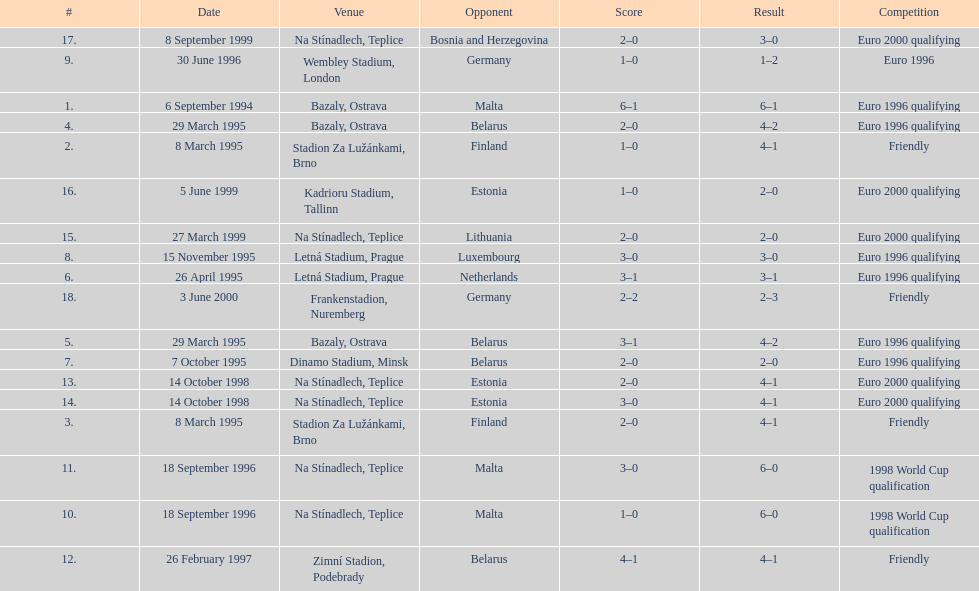List the opponent in which the result was the least out of all the results. Germany. Can you give me this table as a dict? {'header': ['#', 'Date', 'Venue', 'Opponent', 'Score', 'Result', 'Competition'], 'rows': [['17.', '8 September 1999', 'Na Stínadlech, Teplice', 'Bosnia and Herzegovina', '2–0', '3–0', 'Euro 2000 qualifying'], ['9.', '30 June 1996', 'Wembley Stadium, London', 'Germany', '1–0', '1–2', 'Euro 1996'], ['1.', '6 September 1994', 'Bazaly, Ostrava', 'Malta', '6–1', '6–1', 'Euro 1996 qualifying'], ['4.', '29 March 1995', 'Bazaly, Ostrava', 'Belarus', '2–0', '4–2', 'Euro 1996 qualifying'], ['2.', '8 March 1995', 'Stadion Za Lužánkami, Brno', 'Finland', '1–0', '4–1', 'Friendly'], ['16.', '5 June 1999', 'Kadrioru Stadium, Tallinn', 'Estonia', '1–0', '2–0', 'Euro 2000 qualifying'], ['15.', '27 March 1999', 'Na Stínadlech, Teplice', 'Lithuania', '2–0', '2–0', 'Euro 2000 qualifying'], ['8.', '15 November 1995', 'Letná Stadium, Prague', 'Luxembourg', '3–0', '3–0', 'Euro 1996 qualifying'], ['6.', '26 April 1995', 'Letná Stadium, Prague', 'Netherlands', '3–1', '3–1', 'Euro 1996 qualifying'], ['18.', '3 June 2000', 'Frankenstadion, Nuremberg', 'Germany', '2–2', '2–3', 'Friendly'], ['5.', '29 March 1995', 'Bazaly, Ostrava', 'Belarus', '3–1', '4–2', 'Euro 1996 qualifying'], ['7.', '7 October 1995', 'Dinamo Stadium, Minsk', 'Belarus', '2–0', '2–0', 'Euro 1996 qualifying'], ['13.', '14 October 1998', 'Na Stínadlech, Teplice', 'Estonia', '2–0', '4–1', 'Euro 2000 qualifying'], ['14.', '14 October 1998', 'Na Stínadlech, Teplice', 'Estonia', '3–0', '4–1', 'Euro 2000 qualifying'], ['3.', '8 March 1995', 'Stadion Za Lužánkami, Brno', 'Finland', '2–0', '4–1', 'Friendly'], ['11.', '18 September 1996', 'Na Stínadlech, Teplice', 'Malta', '3–0', '6–0', '1998 World Cup qualification'], ['10.', '18 September 1996', 'Na Stínadlech, Teplice', 'Malta', '1–0', '6–0', '1998 World Cup qualification'], ['12.', '26 February 1997', 'Zimní Stadion, Podebrady', 'Belarus', '4–1', '4–1', 'Friendly']]} 